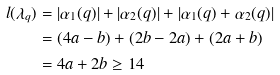Convert formula to latex. <formula><loc_0><loc_0><loc_500><loc_500>l ( \lambda _ { q } ) & = | \alpha _ { 1 } ( q ) | + | \alpha _ { 2 } ( q ) | + | \alpha _ { 1 } ( q ) + \alpha _ { 2 } ( q ) | \\ & = ( 4 a - b ) + ( 2 b - 2 a ) + ( 2 a + b ) \\ & = 4 a + 2 b \geq 1 4</formula> 